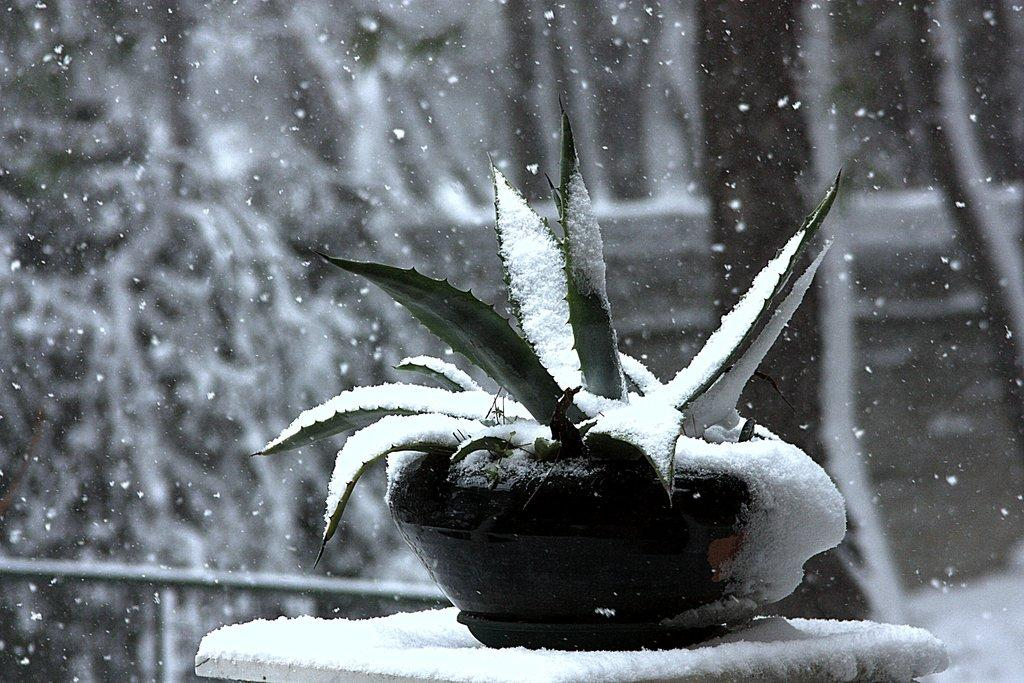What type of living organism can be seen in the image? There is a plant in the image. What is the weather like in the image? There is snow visible in the image, which suggests a cold or wintery environment. What type of vegetation is present in the image? There are many trees in the image. Can you see any visible veins on the duck in the image? There is no duck present in the image, so there are no visible veins to observe. 